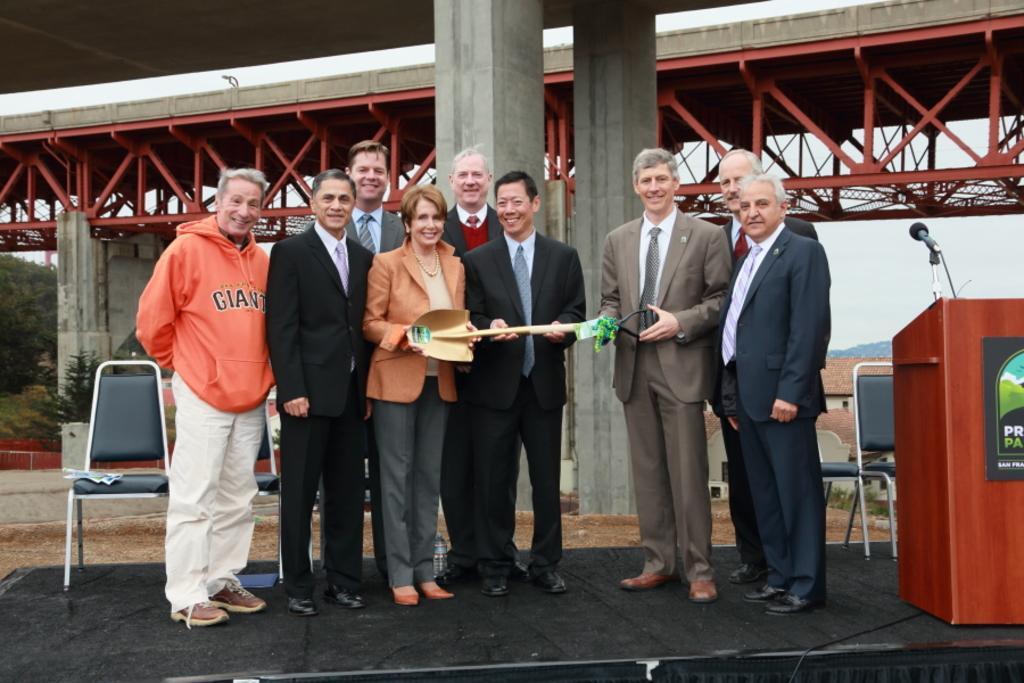How would you summarize this image in a sentence or two? This image consists of many people standing. At the bottom, there is a dais in black color. To the right, there is a podium along with a mic. In the background, there are pillars and a bridge. 